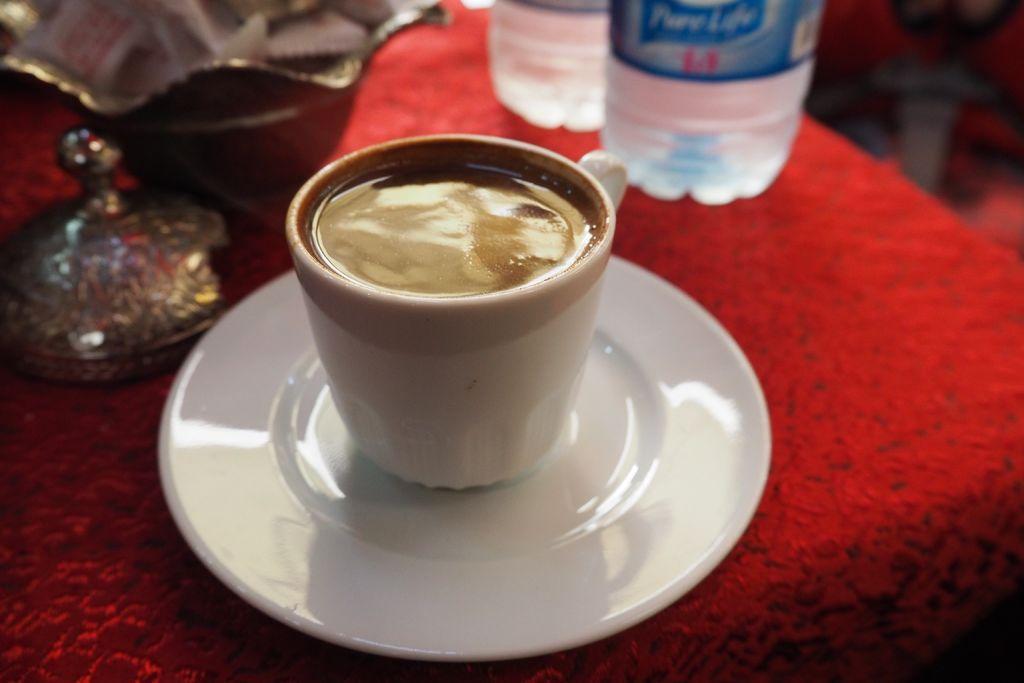Describe this image in one or two sentences. In this picture we can see cup with coffee in it, saucer, bottle, box, some red color cloth. 